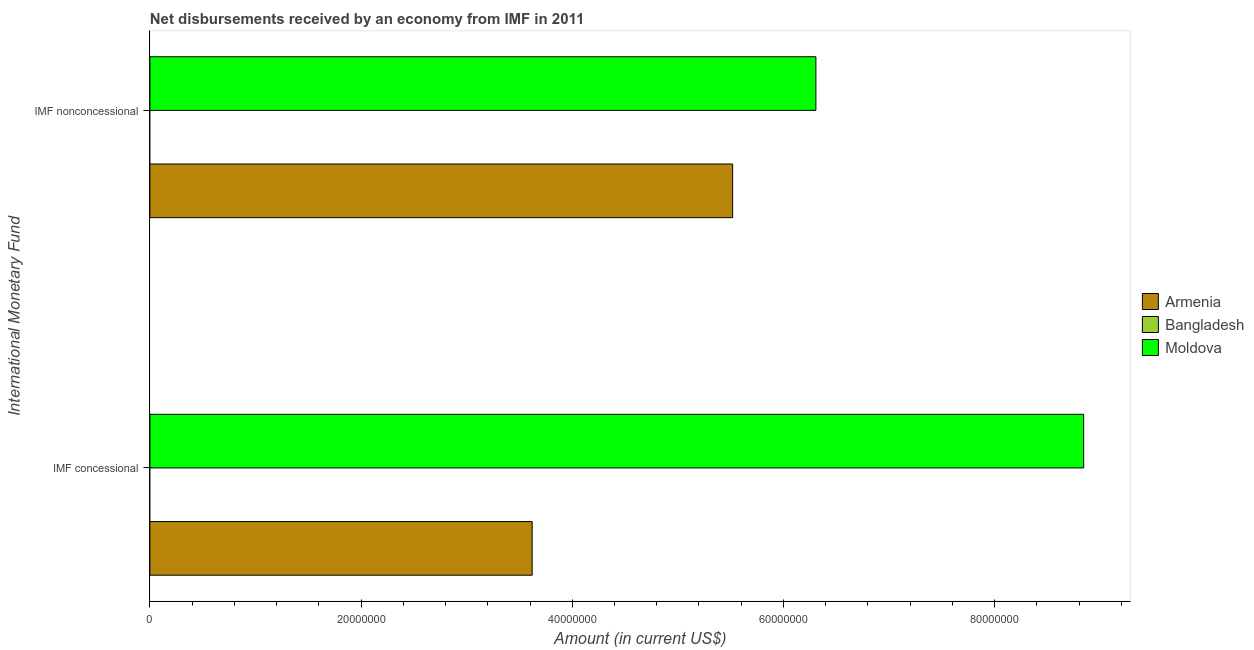How many bars are there on the 1st tick from the top?
Keep it short and to the point. 2. What is the label of the 1st group of bars from the top?
Give a very brief answer. IMF nonconcessional. What is the net non concessional disbursements from imf in Armenia?
Offer a terse response. 5.52e+07. Across all countries, what is the maximum net concessional disbursements from imf?
Offer a terse response. 8.84e+07. In which country was the net non concessional disbursements from imf maximum?
Provide a short and direct response. Moldova. What is the total net non concessional disbursements from imf in the graph?
Provide a short and direct response. 1.18e+08. What is the difference between the net concessional disbursements from imf in Armenia and that in Moldova?
Make the answer very short. -5.22e+07. What is the difference between the net non concessional disbursements from imf in Moldova and the net concessional disbursements from imf in Armenia?
Offer a terse response. 2.69e+07. What is the average net concessional disbursements from imf per country?
Make the answer very short. 4.15e+07. What is the difference between the net non concessional disbursements from imf and net concessional disbursements from imf in Armenia?
Ensure brevity in your answer.  1.90e+07. What is the ratio of the net non concessional disbursements from imf in Moldova to that in Armenia?
Your response must be concise. 1.14. Is the net concessional disbursements from imf in Armenia less than that in Moldova?
Ensure brevity in your answer.  Yes. In how many countries, is the net concessional disbursements from imf greater than the average net concessional disbursements from imf taken over all countries?
Provide a succinct answer. 1. How many bars are there?
Make the answer very short. 4. Are all the bars in the graph horizontal?
Give a very brief answer. Yes. How many countries are there in the graph?
Provide a short and direct response. 3. What is the difference between two consecutive major ticks on the X-axis?
Provide a short and direct response. 2.00e+07. Does the graph contain grids?
Ensure brevity in your answer.  No. How many legend labels are there?
Keep it short and to the point. 3. How are the legend labels stacked?
Keep it short and to the point. Vertical. What is the title of the graph?
Offer a terse response. Net disbursements received by an economy from IMF in 2011. Does "Bulgaria" appear as one of the legend labels in the graph?
Offer a very short reply. No. What is the label or title of the X-axis?
Your answer should be very brief. Amount (in current US$). What is the label or title of the Y-axis?
Make the answer very short. International Monetary Fund. What is the Amount (in current US$) of Armenia in IMF concessional?
Your answer should be compact. 3.62e+07. What is the Amount (in current US$) in Moldova in IMF concessional?
Your response must be concise. 8.84e+07. What is the Amount (in current US$) of Armenia in IMF nonconcessional?
Offer a terse response. 5.52e+07. What is the Amount (in current US$) of Moldova in IMF nonconcessional?
Your answer should be very brief. 6.31e+07. Across all International Monetary Fund, what is the maximum Amount (in current US$) of Armenia?
Your answer should be very brief. 5.52e+07. Across all International Monetary Fund, what is the maximum Amount (in current US$) of Moldova?
Give a very brief answer. 8.84e+07. Across all International Monetary Fund, what is the minimum Amount (in current US$) of Armenia?
Ensure brevity in your answer.  3.62e+07. Across all International Monetary Fund, what is the minimum Amount (in current US$) of Moldova?
Keep it short and to the point. 6.31e+07. What is the total Amount (in current US$) in Armenia in the graph?
Provide a short and direct response. 9.14e+07. What is the total Amount (in current US$) in Moldova in the graph?
Offer a terse response. 1.52e+08. What is the difference between the Amount (in current US$) in Armenia in IMF concessional and that in IMF nonconcessional?
Your response must be concise. -1.90e+07. What is the difference between the Amount (in current US$) of Moldova in IMF concessional and that in IMF nonconcessional?
Provide a succinct answer. 2.54e+07. What is the difference between the Amount (in current US$) of Armenia in IMF concessional and the Amount (in current US$) of Moldova in IMF nonconcessional?
Ensure brevity in your answer.  -2.69e+07. What is the average Amount (in current US$) in Armenia per International Monetary Fund?
Make the answer very short. 4.57e+07. What is the average Amount (in current US$) in Bangladesh per International Monetary Fund?
Keep it short and to the point. 0. What is the average Amount (in current US$) in Moldova per International Monetary Fund?
Offer a terse response. 7.58e+07. What is the difference between the Amount (in current US$) in Armenia and Amount (in current US$) in Moldova in IMF concessional?
Offer a terse response. -5.22e+07. What is the difference between the Amount (in current US$) in Armenia and Amount (in current US$) in Moldova in IMF nonconcessional?
Offer a terse response. -7.88e+06. What is the ratio of the Amount (in current US$) of Armenia in IMF concessional to that in IMF nonconcessional?
Your answer should be compact. 0.66. What is the ratio of the Amount (in current US$) in Moldova in IMF concessional to that in IMF nonconcessional?
Provide a short and direct response. 1.4. What is the difference between the highest and the second highest Amount (in current US$) in Armenia?
Your answer should be very brief. 1.90e+07. What is the difference between the highest and the second highest Amount (in current US$) of Moldova?
Your answer should be very brief. 2.54e+07. What is the difference between the highest and the lowest Amount (in current US$) in Armenia?
Make the answer very short. 1.90e+07. What is the difference between the highest and the lowest Amount (in current US$) of Moldova?
Ensure brevity in your answer.  2.54e+07. 